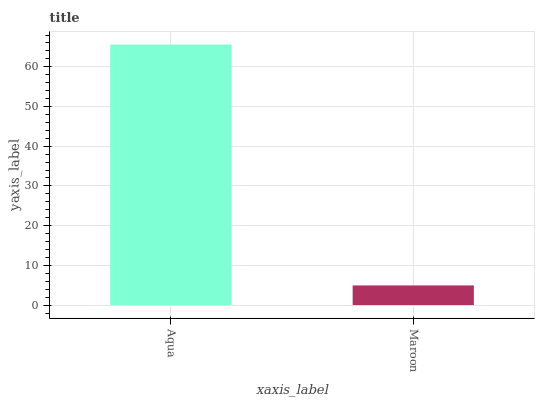Is Maroon the minimum?
Answer yes or no. Yes. Is Aqua the maximum?
Answer yes or no. Yes. Is Maroon the maximum?
Answer yes or no. No. Is Aqua greater than Maroon?
Answer yes or no. Yes. Is Maroon less than Aqua?
Answer yes or no. Yes. Is Maroon greater than Aqua?
Answer yes or no. No. Is Aqua less than Maroon?
Answer yes or no. No. Is Aqua the high median?
Answer yes or no. Yes. Is Maroon the low median?
Answer yes or no. Yes. Is Maroon the high median?
Answer yes or no. No. Is Aqua the low median?
Answer yes or no. No. 